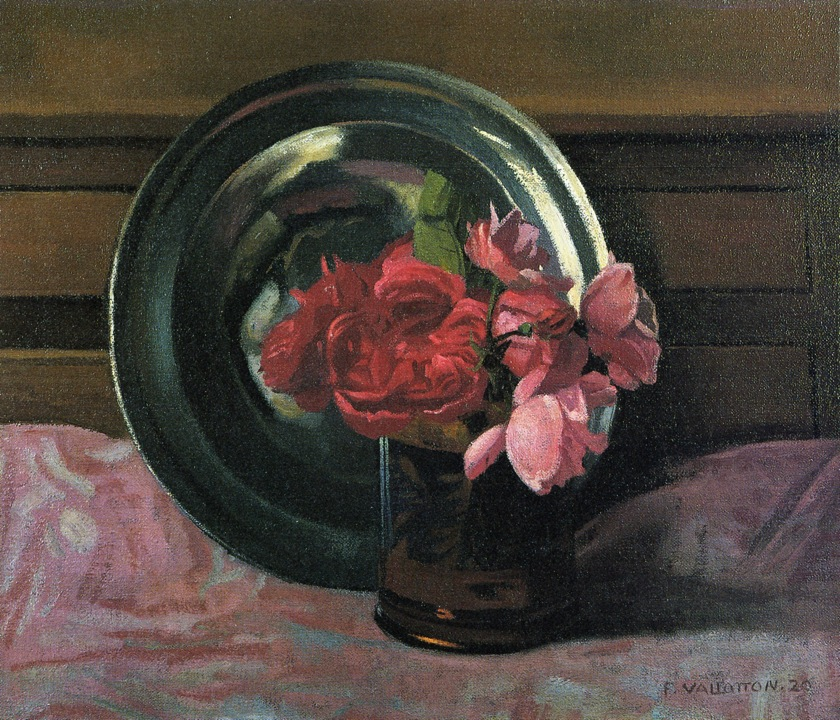Write a detailed description of the given image. The image is a captivating oil painting that embodies a still-life composition in a highly realistic style. The central focus of the artwork is a vase filled with exquisitely detailed roses, showcasing vibrant hues of reds and pinks. These blooms stand in dramatic contrast to the more subdued, muted tones that dominate the rest of the piece. The vase is placed delicately on a table adorned with a pinkish cloth whose subtle folds add a sense of depth and texture. Behind the roses, a green metallic plate acts as a backdrop, further accentuating the vivid colors of the flowers. The meticulous attention to detail and the accurate representation of the objects confirm the painting's adherence to the realism genre, creating an overall composition that exudes tranquility and refined elegance. 